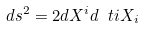Convert formula to latex. <formula><loc_0><loc_0><loc_500><loc_500>d s ^ { 2 } = 2 d X ^ { i } d \ t i X _ { i }</formula> 